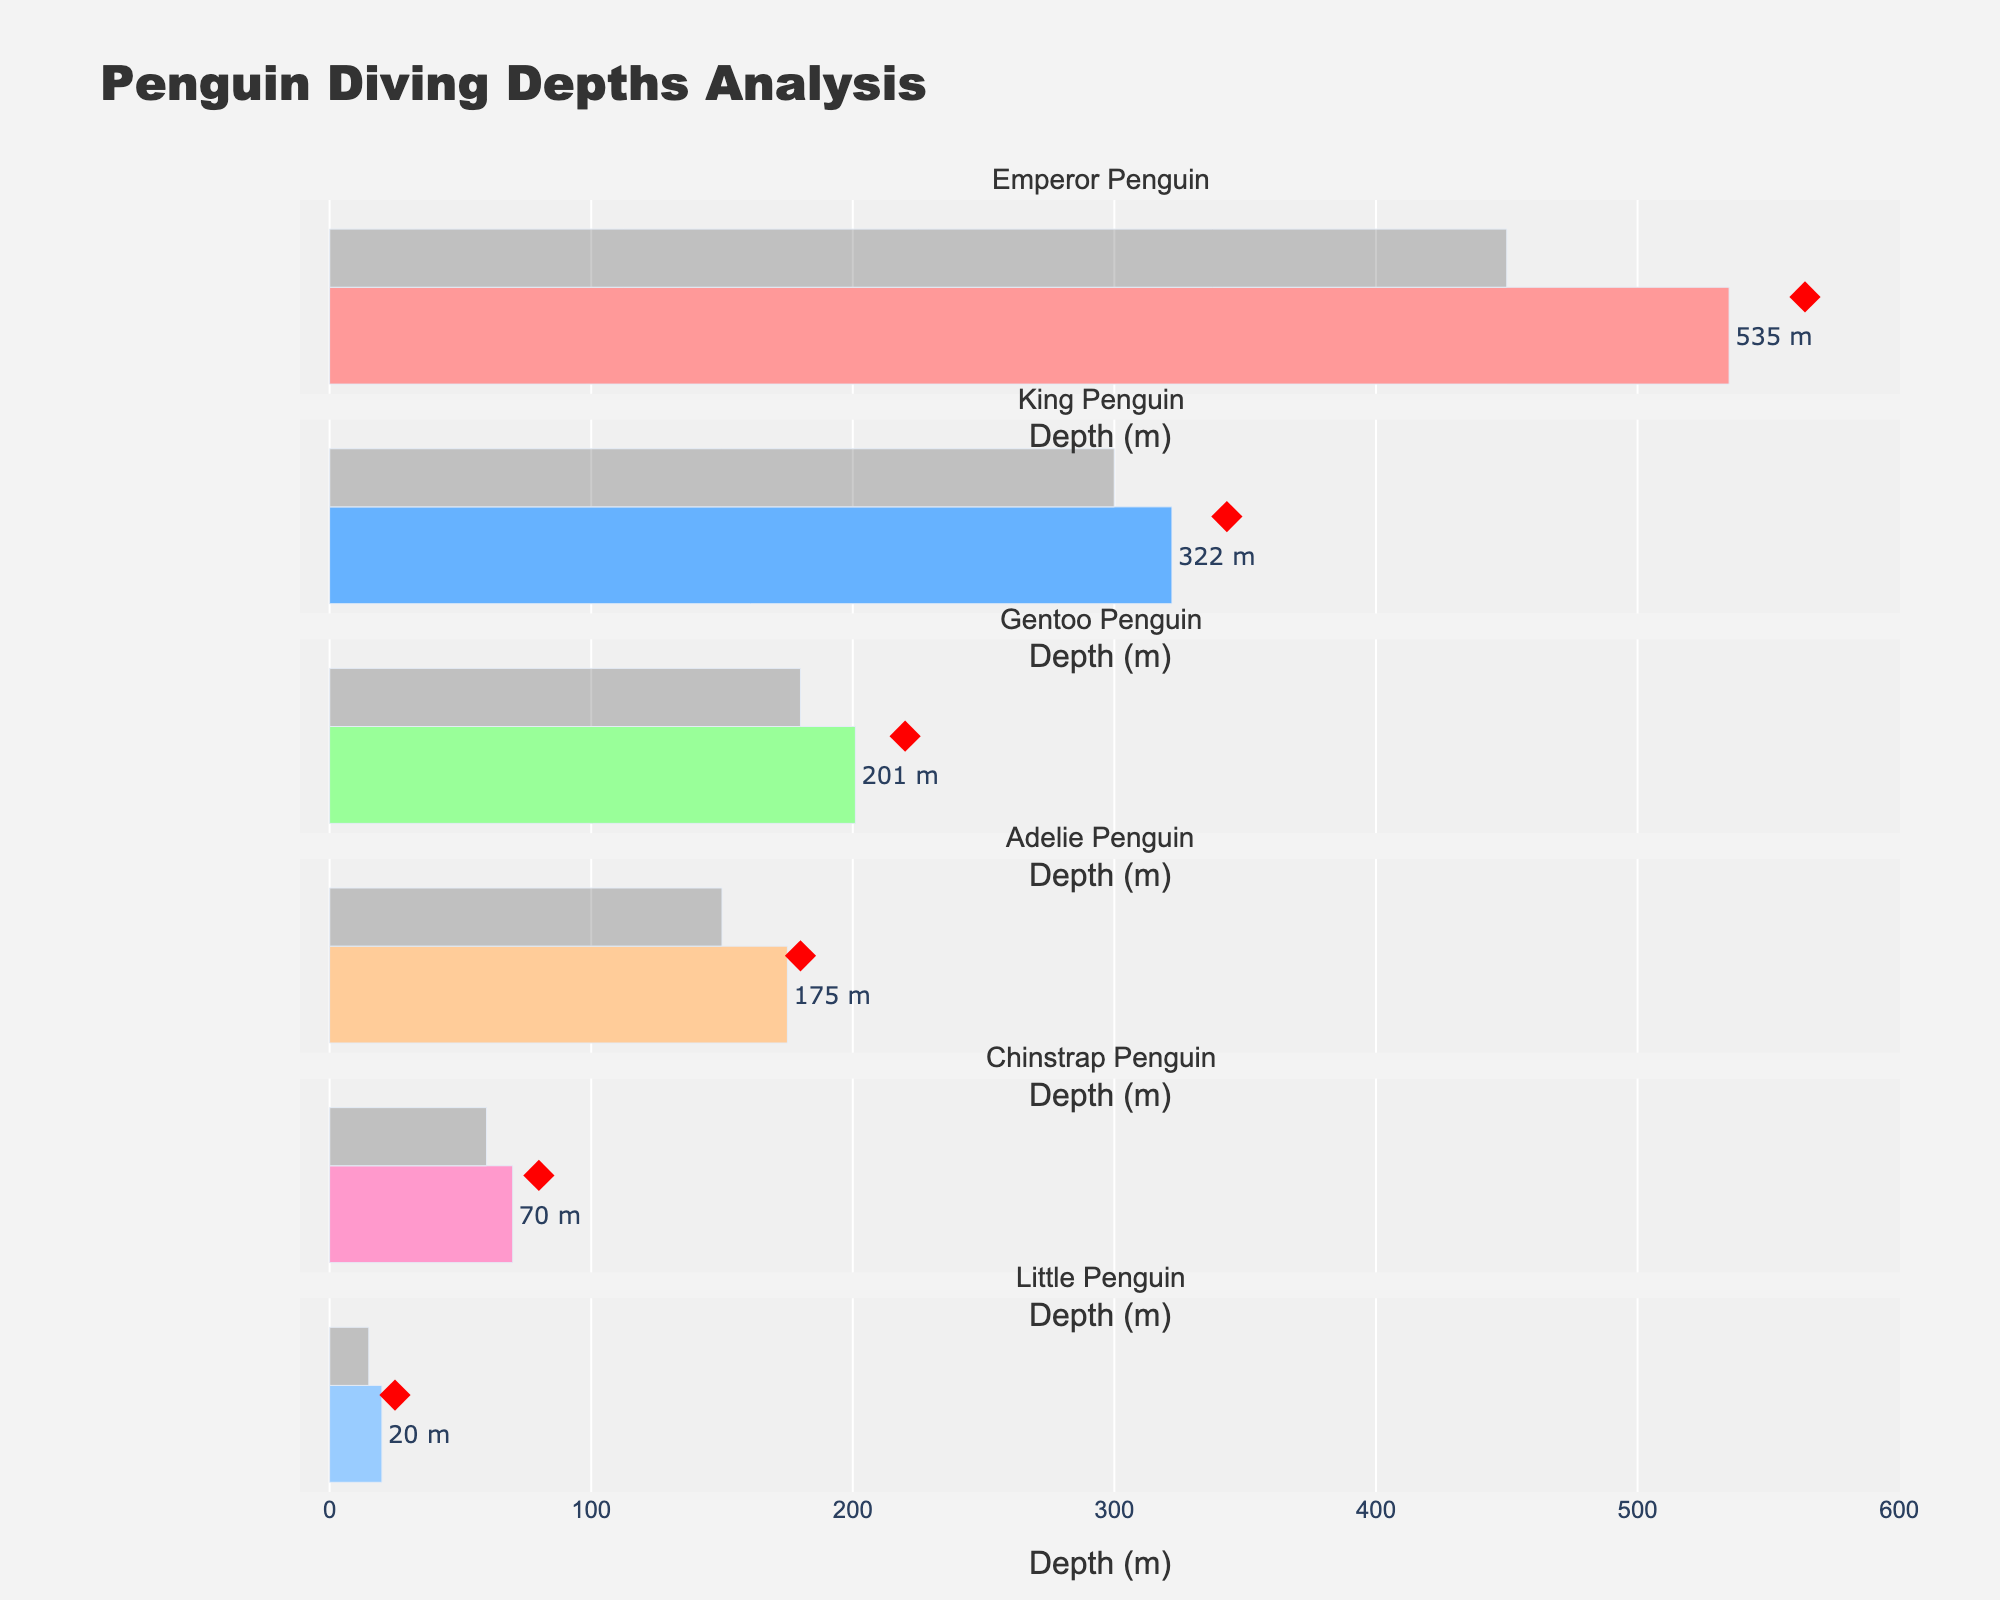What is the title of the figure? The title is located at the top of the figure and is typically larger and bold compared to other text elements.
Answer: Penguin Diving Depths Analysis Which penguin species has the deepest actual diving depth? By looking at the horizontal bars representing actual diving depths, identify the longest bar. The Emperor Penguin's bar is the longest.
Answer: Emperor Penguin What color represents the expected diving depth? The color for the expected diving depth appears consistently lighter and semi-transparent across all bars.
Answer: Light gray (semi-transparent) Which penguin species has the smallest difference between its actual diving depth and expected diving depth? Calculate the difference for each species: Emperor (535-450=85), King (322-300=22), Gentoo (201-180=21), Adelie (175-150=25), Chinstrap (70-60=10), Little Penguin (20-15=5). The Little Penguin has the smallest difference.
Answer: Little Penguin What symbol is used to represent the maximum recorded depth? The maximum recorded depth is represented by a specific marker which is different from the bar. It is shown as red diamonds.
Answer: Diamond Which penguin species' actual diving depth surpasses its maximum recorded depth? Compare the actual diving depth bar with the diamond marker. For Emperor Penguins, the actual depth of 535m is less than the maximum recorded depth of 564m. Repeat the process for all species and observe that none surpass their maximum recorded depth.
Answer: None Of all the penguin species, how many have an actual diving depth greater than their expected diving depth? Count the species where the actual diving depth bar is longer than the expected diving depth bar. Emperor, King, Gentoo, Adelie, and Chinstrap Penguins fall into this category.
Answer: Five Which penguin species has the shallowest actual diving depth? Identify the shortest horizontal bar representing actual diving depths. It belongs to the Little Penguin.
Answer: Little Penguin How much deeper can the Gentoo Penguin dive compared to its expected diving depth? Subtract the expected diving depth from the actual diving depth for Gentoo Penguins: 201m - 180m = 21m.
Answer: 21m 